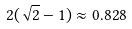Convert formula to latex. <formula><loc_0><loc_0><loc_500><loc_500>2 ( \sqrt { 2 } - 1 ) \approx 0 . 8 2 8</formula> 